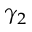<formula> <loc_0><loc_0><loc_500><loc_500>\gamma _ { 2 }</formula> 